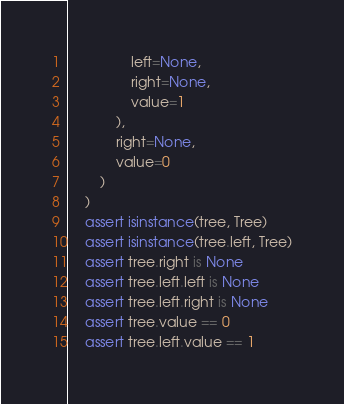<code> <loc_0><loc_0><loc_500><loc_500><_Python_>                left=None,
                right=None,
                value=1
            ),
            right=None,
            value=0
        )
    )
    assert isinstance(tree, Tree)
    assert isinstance(tree.left, Tree)
    assert tree.right is None
    assert tree.left.left is None
    assert tree.left.right is None
    assert tree.value == 0
    assert tree.left.value == 1

</code> 